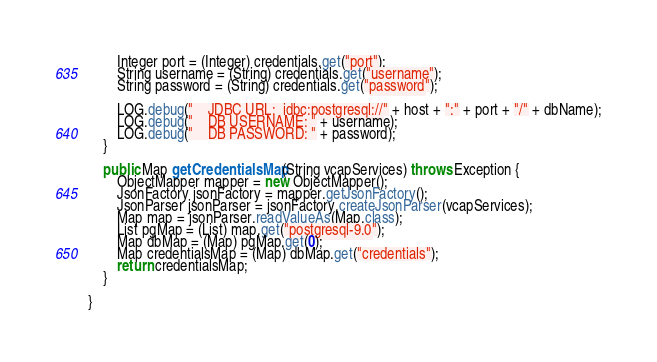<code> <loc_0><loc_0><loc_500><loc_500><_Java_>		Integer port = (Integer) credentials.get("port");
		String username = (String) credentials.get("username");
		String password = (String) credentials.get("password");

		LOG.debug("    JDBC URL:  jdbc:postgresql://" + host + ":" + port + "/" + dbName);
		LOG.debug("    DB USERNAME: " + username);
		LOG.debug("    DB PASSWORD: " + password);
	}

	public Map getCredentialsMap(String vcapServices) throws Exception {
		ObjectMapper mapper = new ObjectMapper();
		JsonFactory jsonFactory = mapper.getJsonFactory();
		JsonParser jsonParser = jsonFactory.createJsonParser(vcapServices);
		Map map = jsonParser.readValueAs(Map.class);
		List pgMap = (List) map.get("postgresql-9.0");
		Map dbMap = (Map) pgMap.get(0);
		Map credentialsMap = (Map) dbMap.get("credentials");
		return credentialsMap;
	}

}
</code> 